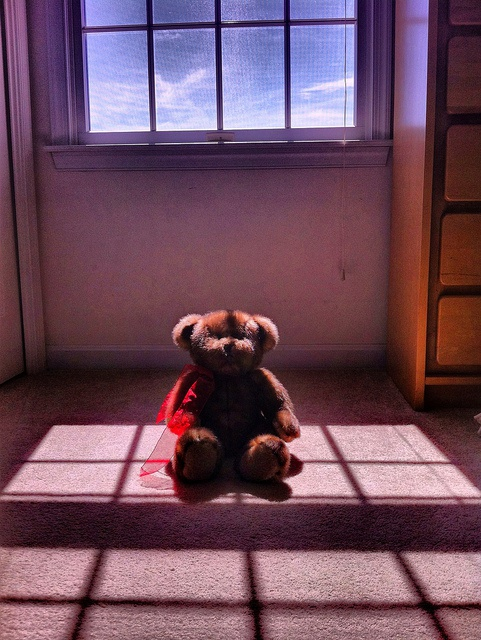Describe the objects in this image and their specific colors. I can see a teddy bear in black, maroon, brown, and lightpink tones in this image. 